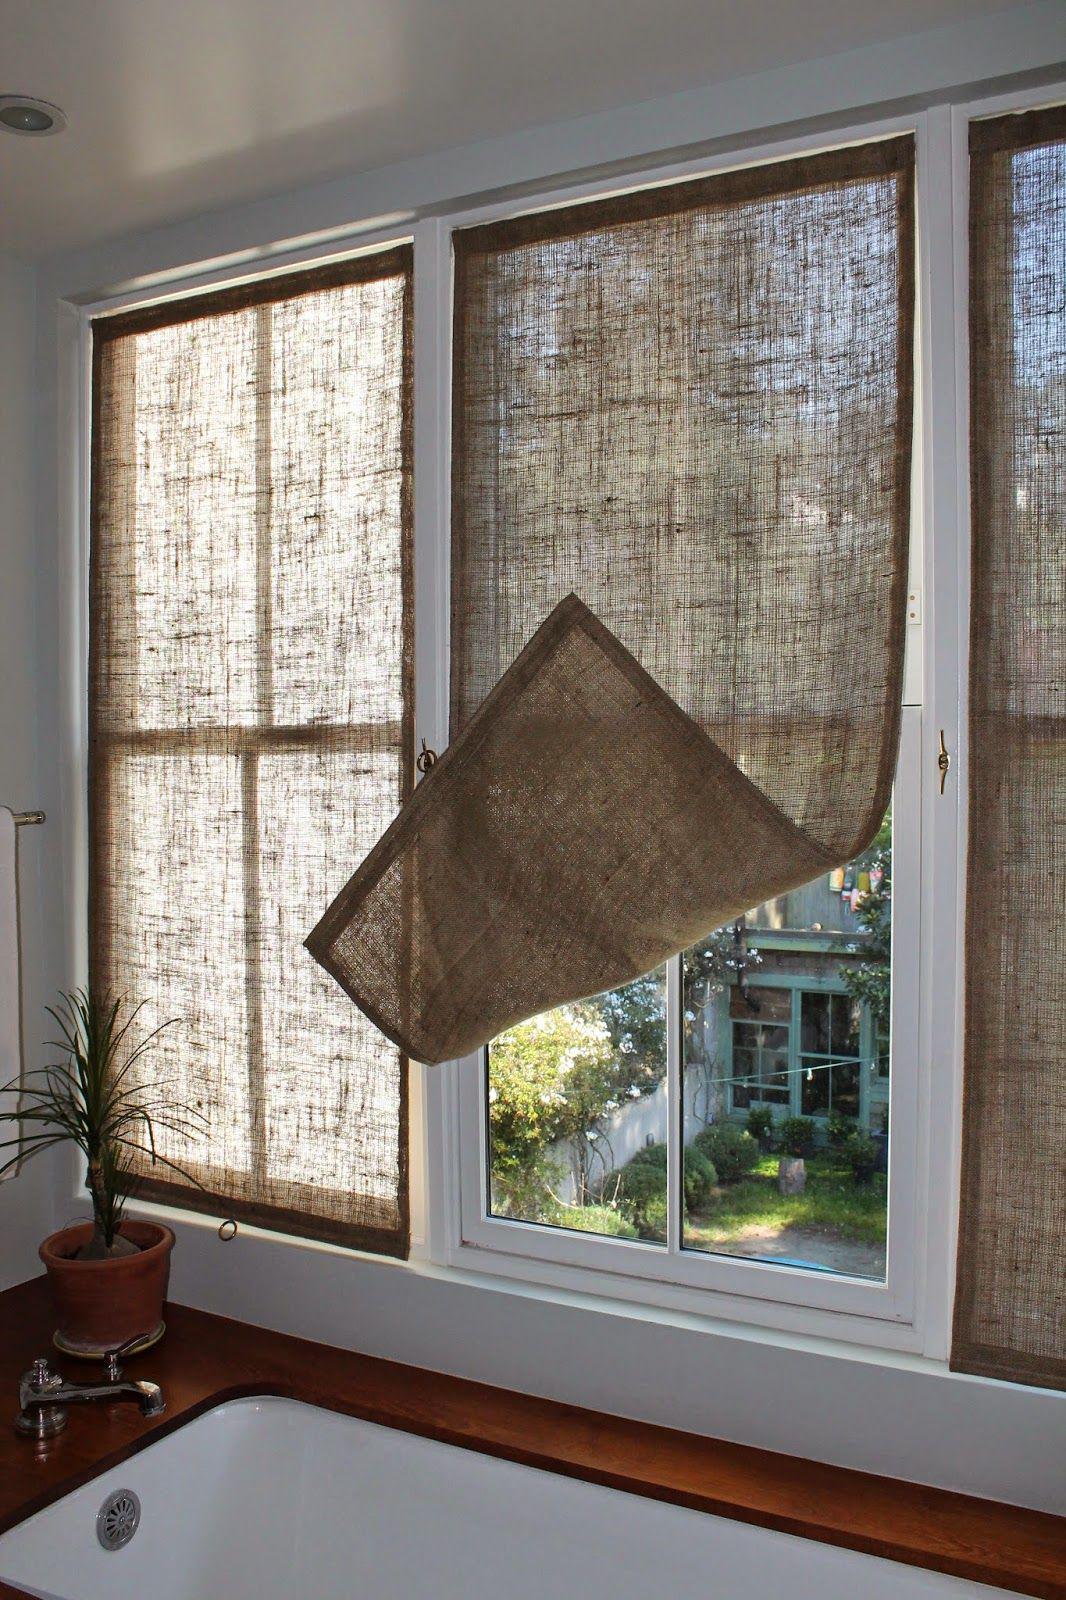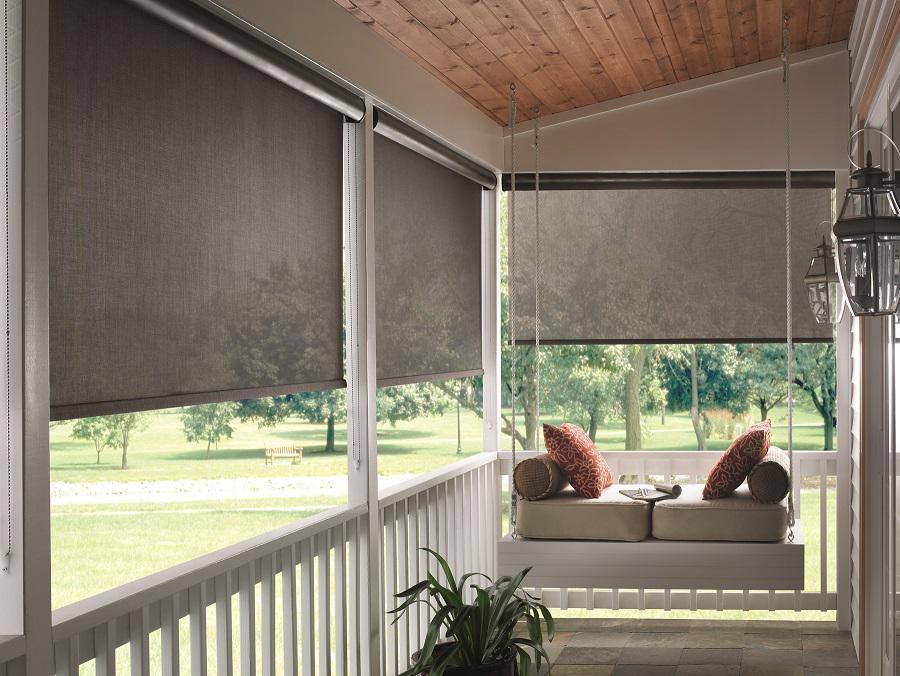The first image is the image on the left, the second image is the image on the right. Examine the images to the left and right. Is the description "Some shades are partially up." accurate? Answer yes or no. Yes. The first image is the image on the left, the second image is the image on the right. Examine the images to the left and right. Is the description "There are six blinds or window coverings." accurate? Answer yes or no. Yes. 